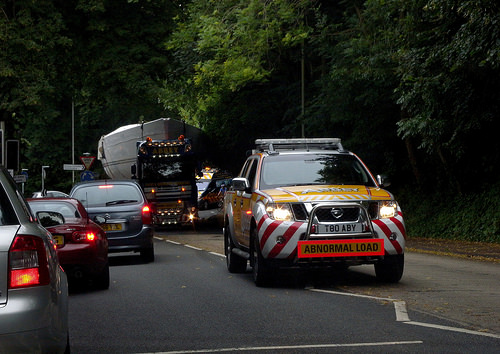<image>
Is the car on the road? Yes. Looking at the image, I can see the car is positioned on top of the road, with the road providing support. Is there a pilot car behind the load truck? No. The pilot car is not behind the load truck. From this viewpoint, the pilot car appears to be positioned elsewhere in the scene. 